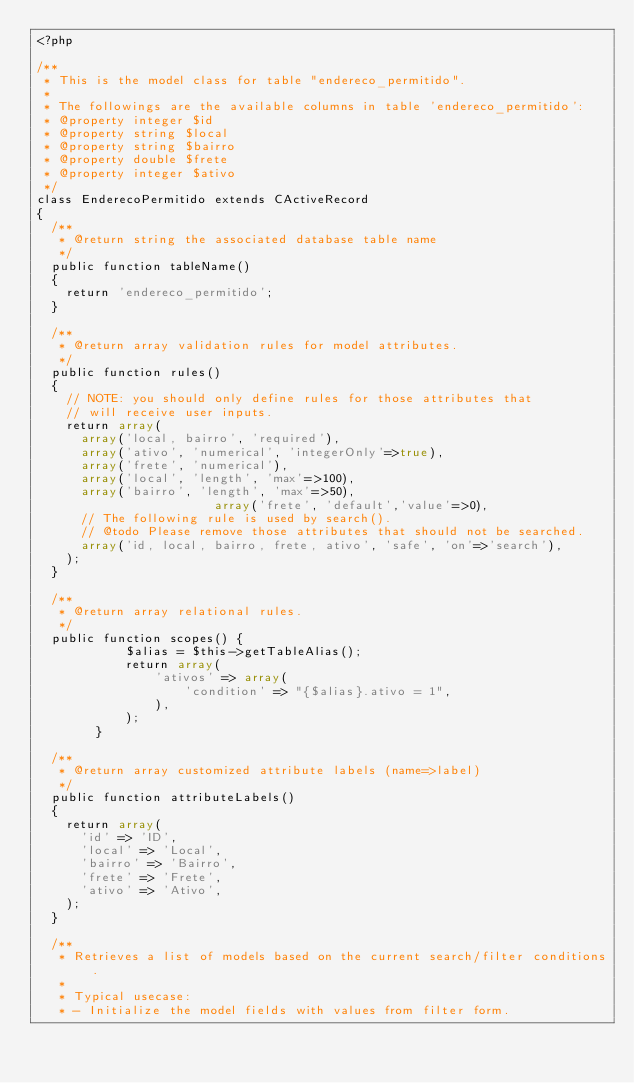Convert code to text. <code><loc_0><loc_0><loc_500><loc_500><_PHP_><?php

/**
 * This is the model class for table "endereco_permitido".
 *
 * The followings are the available columns in table 'endereco_permitido':
 * @property integer $id
 * @property string $local
 * @property string $bairro
 * @property double $frete
 * @property integer $ativo
 */
class EnderecoPermitido extends CActiveRecord
{
	/**
	 * @return string the associated database table name
	 */
	public function tableName()
	{
		return 'endereco_permitido';
	}

	/**
	 * @return array validation rules for model attributes.
	 */
	public function rules()
	{
		// NOTE: you should only define rules for those attributes that
		// will receive user inputs.
		return array(
			array('local, bairro', 'required'),
			array('ativo', 'numerical', 'integerOnly'=>true),
			array('frete', 'numerical'),
			array('local', 'length', 'max'=>100),
			array('bairro', 'length', 'max'=>50),
                        array('frete', 'default','value'=>0),
			// The following rule is used by search().
			// @todo Please remove those attributes that should not be searched.
			array('id, local, bairro, frete, ativo', 'safe', 'on'=>'search'),
		);
	}

	/**
	 * @return array relational rules.
	 */
	public function scopes() {
            $alias = $this->getTableAlias();
            return array(
                'ativos' => array(
                    'condition' => "{$alias}.ativo = 1",
                ),
            );
        }

	/**
	 * @return array customized attribute labels (name=>label)
	 */
	public function attributeLabels()
	{
		return array(
			'id' => 'ID',
			'local' => 'Local',
			'bairro' => 'Bairro',
			'frete' => 'Frete',
			'ativo' => 'Ativo',
		);
	}

	/**
	 * Retrieves a list of models based on the current search/filter conditions.
	 *
	 * Typical usecase:
	 * - Initialize the model fields with values from filter form.</code> 